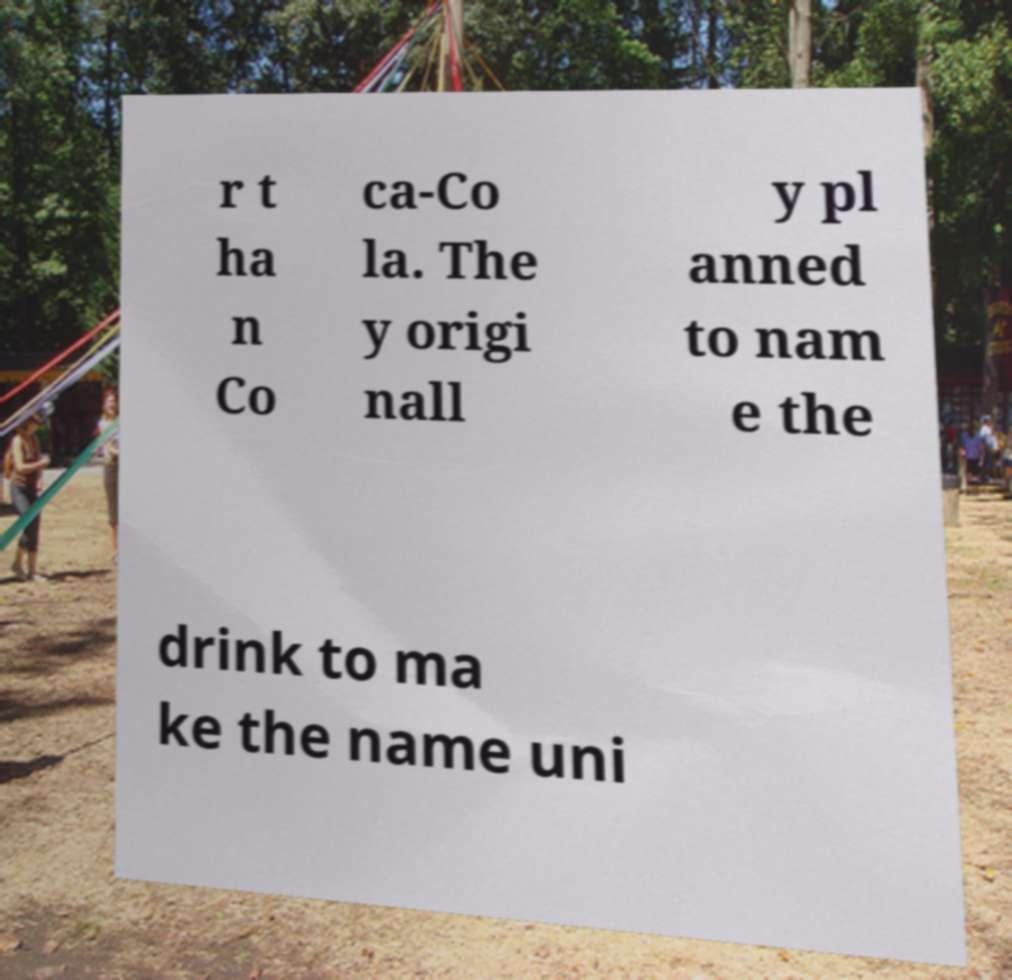Could you assist in decoding the text presented in this image and type it out clearly? r t ha n Co ca-Co la. The y origi nall y pl anned to nam e the drink to ma ke the name uni 